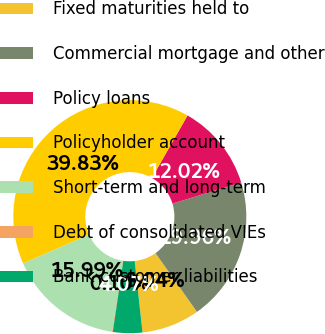Convert chart to OTSL. <chart><loc_0><loc_0><loc_500><loc_500><pie_chart><fcel>Fixed maturities held to<fcel>Commercial mortgage and other<fcel>Policy loans<fcel>Policyholder account<fcel>Short-term and long-term<fcel>Debt of consolidated VIEs<fcel>Bank customer liabilities<nl><fcel>8.04%<fcel>19.96%<fcel>12.02%<fcel>39.83%<fcel>15.99%<fcel>0.1%<fcel>4.07%<nl></chart> 